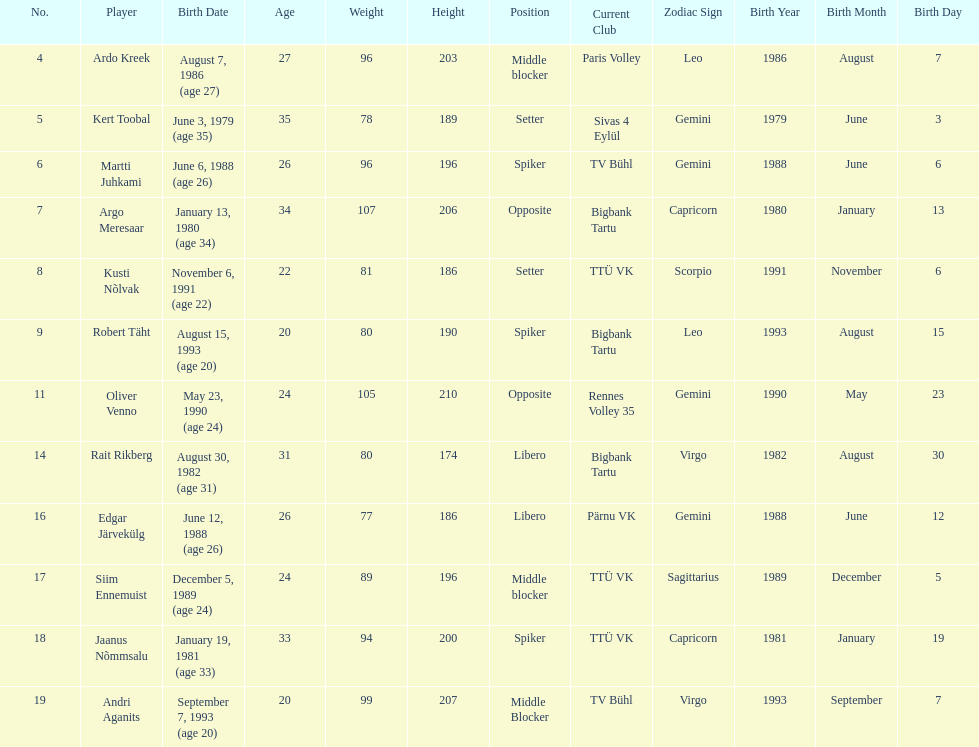Which participants performed the same spot as ardo kreek? Siim Ennemuist, Andri Aganits. 